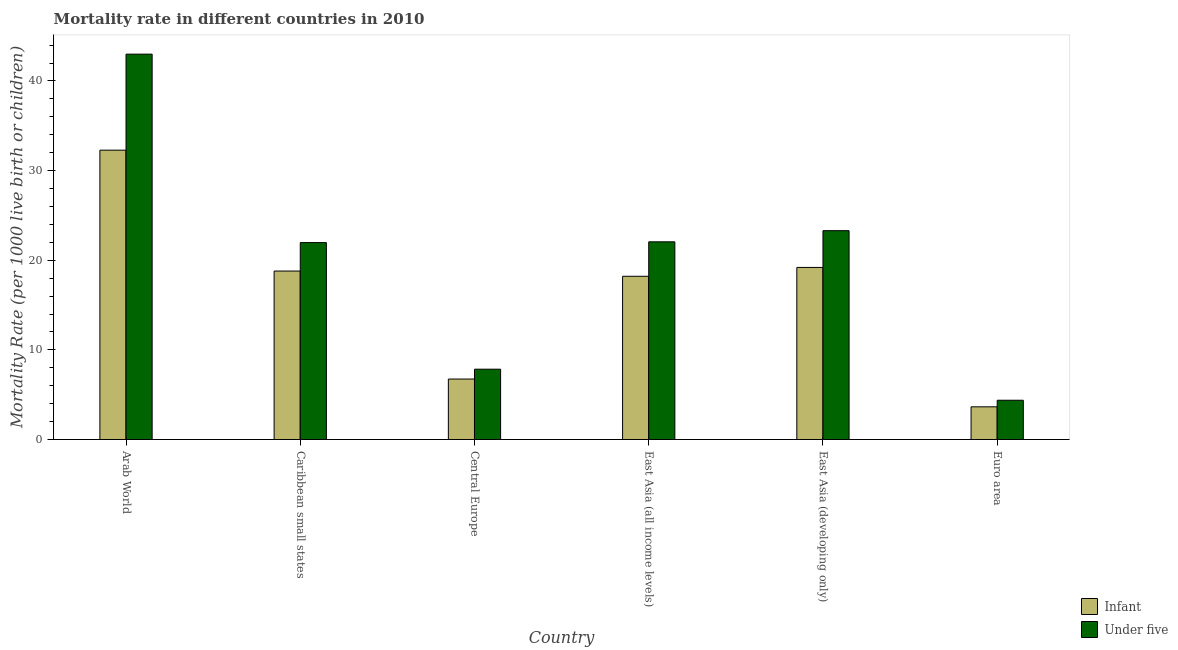How many groups of bars are there?
Your response must be concise. 6. How many bars are there on the 4th tick from the left?
Keep it short and to the point. 2. What is the label of the 5th group of bars from the left?
Offer a terse response. East Asia (developing only). In how many cases, is the number of bars for a given country not equal to the number of legend labels?
Your answer should be compact. 0. What is the under-5 mortality rate in Euro area?
Your answer should be compact. 4.38. Across all countries, what is the maximum under-5 mortality rate?
Ensure brevity in your answer.  42.99. Across all countries, what is the minimum infant mortality rate?
Your answer should be very brief. 3.65. In which country was the infant mortality rate maximum?
Your answer should be compact. Arab World. What is the total under-5 mortality rate in the graph?
Offer a very short reply. 122.55. What is the difference between the under-5 mortality rate in East Asia (all income levels) and that in Euro area?
Your response must be concise. 17.67. What is the difference between the under-5 mortality rate in East Asia (all income levels) and the infant mortality rate in Arab World?
Give a very brief answer. -10.23. What is the average under-5 mortality rate per country?
Give a very brief answer. 20.42. What is the difference between the under-5 mortality rate and infant mortality rate in Arab World?
Your answer should be very brief. 10.71. What is the ratio of the under-5 mortality rate in Central Europe to that in East Asia (all income levels)?
Make the answer very short. 0.36. Is the under-5 mortality rate in East Asia (all income levels) less than that in East Asia (developing only)?
Ensure brevity in your answer.  Yes. What is the difference between the highest and the second highest under-5 mortality rate?
Offer a very short reply. 19.69. What is the difference between the highest and the lowest under-5 mortality rate?
Your answer should be compact. 38.61. What does the 1st bar from the left in Caribbean small states represents?
Your answer should be very brief. Infant. What does the 2nd bar from the right in Euro area represents?
Ensure brevity in your answer.  Infant. How many bars are there?
Offer a terse response. 12. Does the graph contain any zero values?
Your answer should be compact. No. What is the title of the graph?
Ensure brevity in your answer.  Mortality rate in different countries in 2010. Does "Technicians" appear as one of the legend labels in the graph?
Make the answer very short. No. What is the label or title of the X-axis?
Provide a succinct answer. Country. What is the label or title of the Y-axis?
Offer a terse response. Mortality Rate (per 1000 live birth or children). What is the Mortality Rate (per 1000 live birth or children) of Infant in Arab World?
Offer a terse response. 32.28. What is the Mortality Rate (per 1000 live birth or children) in Under five in Arab World?
Provide a succinct answer. 42.99. What is the Mortality Rate (per 1000 live birth or children) of Infant in Caribbean small states?
Keep it short and to the point. 18.8. What is the Mortality Rate (per 1000 live birth or children) in Under five in Caribbean small states?
Provide a succinct answer. 21.97. What is the Mortality Rate (per 1000 live birth or children) in Infant in Central Europe?
Your answer should be compact. 6.75. What is the Mortality Rate (per 1000 live birth or children) in Under five in Central Europe?
Give a very brief answer. 7.85. What is the Mortality Rate (per 1000 live birth or children) of Infant in East Asia (all income levels)?
Ensure brevity in your answer.  18.21. What is the Mortality Rate (per 1000 live birth or children) of Under five in East Asia (all income levels)?
Your response must be concise. 22.06. What is the Mortality Rate (per 1000 live birth or children) of Under five in East Asia (developing only)?
Make the answer very short. 23.3. What is the Mortality Rate (per 1000 live birth or children) of Infant in Euro area?
Your response must be concise. 3.65. What is the Mortality Rate (per 1000 live birth or children) in Under five in Euro area?
Make the answer very short. 4.38. Across all countries, what is the maximum Mortality Rate (per 1000 live birth or children) of Infant?
Keep it short and to the point. 32.28. Across all countries, what is the maximum Mortality Rate (per 1000 live birth or children) of Under five?
Keep it short and to the point. 42.99. Across all countries, what is the minimum Mortality Rate (per 1000 live birth or children) in Infant?
Provide a succinct answer. 3.65. Across all countries, what is the minimum Mortality Rate (per 1000 live birth or children) of Under five?
Offer a very short reply. 4.38. What is the total Mortality Rate (per 1000 live birth or children) of Infant in the graph?
Provide a short and direct response. 98.89. What is the total Mortality Rate (per 1000 live birth or children) in Under five in the graph?
Make the answer very short. 122.55. What is the difference between the Mortality Rate (per 1000 live birth or children) of Infant in Arab World and that in Caribbean small states?
Make the answer very short. 13.48. What is the difference between the Mortality Rate (per 1000 live birth or children) in Under five in Arab World and that in Caribbean small states?
Make the answer very short. 21.03. What is the difference between the Mortality Rate (per 1000 live birth or children) of Infant in Arab World and that in Central Europe?
Offer a terse response. 25.54. What is the difference between the Mortality Rate (per 1000 live birth or children) in Under five in Arab World and that in Central Europe?
Your answer should be very brief. 35.15. What is the difference between the Mortality Rate (per 1000 live birth or children) in Infant in Arab World and that in East Asia (all income levels)?
Make the answer very short. 14.07. What is the difference between the Mortality Rate (per 1000 live birth or children) of Under five in Arab World and that in East Asia (all income levels)?
Keep it short and to the point. 20.94. What is the difference between the Mortality Rate (per 1000 live birth or children) of Infant in Arab World and that in East Asia (developing only)?
Your answer should be compact. 13.08. What is the difference between the Mortality Rate (per 1000 live birth or children) of Under five in Arab World and that in East Asia (developing only)?
Your answer should be compact. 19.69. What is the difference between the Mortality Rate (per 1000 live birth or children) in Infant in Arab World and that in Euro area?
Offer a terse response. 28.63. What is the difference between the Mortality Rate (per 1000 live birth or children) in Under five in Arab World and that in Euro area?
Make the answer very short. 38.61. What is the difference between the Mortality Rate (per 1000 live birth or children) of Infant in Caribbean small states and that in Central Europe?
Your response must be concise. 12.05. What is the difference between the Mortality Rate (per 1000 live birth or children) of Under five in Caribbean small states and that in Central Europe?
Your response must be concise. 14.12. What is the difference between the Mortality Rate (per 1000 live birth or children) in Infant in Caribbean small states and that in East Asia (all income levels)?
Provide a succinct answer. 0.59. What is the difference between the Mortality Rate (per 1000 live birth or children) in Under five in Caribbean small states and that in East Asia (all income levels)?
Ensure brevity in your answer.  -0.09. What is the difference between the Mortality Rate (per 1000 live birth or children) in Infant in Caribbean small states and that in East Asia (developing only)?
Your answer should be very brief. -0.4. What is the difference between the Mortality Rate (per 1000 live birth or children) of Under five in Caribbean small states and that in East Asia (developing only)?
Provide a succinct answer. -1.33. What is the difference between the Mortality Rate (per 1000 live birth or children) of Infant in Caribbean small states and that in Euro area?
Make the answer very short. 15.15. What is the difference between the Mortality Rate (per 1000 live birth or children) of Under five in Caribbean small states and that in Euro area?
Offer a very short reply. 17.59. What is the difference between the Mortality Rate (per 1000 live birth or children) of Infant in Central Europe and that in East Asia (all income levels)?
Provide a succinct answer. -11.46. What is the difference between the Mortality Rate (per 1000 live birth or children) of Under five in Central Europe and that in East Asia (all income levels)?
Provide a short and direct response. -14.21. What is the difference between the Mortality Rate (per 1000 live birth or children) of Infant in Central Europe and that in East Asia (developing only)?
Offer a very short reply. -12.45. What is the difference between the Mortality Rate (per 1000 live birth or children) of Under five in Central Europe and that in East Asia (developing only)?
Your answer should be very brief. -15.45. What is the difference between the Mortality Rate (per 1000 live birth or children) of Infant in Central Europe and that in Euro area?
Provide a succinct answer. 3.1. What is the difference between the Mortality Rate (per 1000 live birth or children) of Under five in Central Europe and that in Euro area?
Make the answer very short. 3.46. What is the difference between the Mortality Rate (per 1000 live birth or children) of Infant in East Asia (all income levels) and that in East Asia (developing only)?
Your answer should be compact. -0.99. What is the difference between the Mortality Rate (per 1000 live birth or children) of Under five in East Asia (all income levels) and that in East Asia (developing only)?
Your answer should be compact. -1.24. What is the difference between the Mortality Rate (per 1000 live birth or children) in Infant in East Asia (all income levels) and that in Euro area?
Ensure brevity in your answer.  14.56. What is the difference between the Mortality Rate (per 1000 live birth or children) in Under five in East Asia (all income levels) and that in Euro area?
Keep it short and to the point. 17.67. What is the difference between the Mortality Rate (per 1000 live birth or children) of Infant in East Asia (developing only) and that in Euro area?
Ensure brevity in your answer.  15.55. What is the difference between the Mortality Rate (per 1000 live birth or children) of Under five in East Asia (developing only) and that in Euro area?
Provide a short and direct response. 18.92. What is the difference between the Mortality Rate (per 1000 live birth or children) in Infant in Arab World and the Mortality Rate (per 1000 live birth or children) in Under five in Caribbean small states?
Offer a terse response. 10.31. What is the difference between the Mortality Rate (per 1000 live birth or children) in Infant in Arab World and the Mortality Rate (per 1000 live birth or children) in Under five in Central Europe?
Offer a very short reply. 24.44. What is the difference between the Mortality Rate (per 1000 live birth or children) of Infant in Arab World and the Mortality Rate (per 1000 live birth or children) of Under five in East Asia (all income levels)?
Offer a very short reply. 10.23. What is the difference between the Mortality Rate (per 1000 live birth or children) of Infant in Arab World and the Mortality Rate (per 1000 live birth or children) of Under five in East Asia (developing only)?
Provide a short and direct response. 8.98. What is the difference between the Mortality Rate (per 1000 live birth or children) of Infant in Arab World and the Mortality Rate (per 1000 live birth or children) of Under five in Euro area?
Ensure brevity in your answer.  27.9. What is the difference between the Mortality Rate (per 1000 live birth or children) of Infant in Caribbean small states and the Mortality Rate (per 1000 live birth or children) of Under five in Central Europe?
Give a very brief answer. 10.95. What is the difference between the Mortality Rate (per 1000 live birth or children) in Infant in Caribbean small states and the Mortality Rate (per 1000 live birth or children) in Under five in East Asia (all income levels)?
Give a very brief answer. -3.26. What is the difference between the Mortality Rate (per 1000 live birth or children) in Infant in Caribbean small states and the Mortality Rate (per 1000 live birth or children) in Under five in East Asia (developing only)?
Provide a succinct answer. -4.5. What is the difference between the Mortality Rate (per 1000 live birth or children) of Infant in Caribbean small states and the Mortality Rate (per 1000 live birth or children) of Under five in Euro area?
Offer a very short reply. 14.42. What is the difference between the Mortality Rate (per 1000 live birth or children) in Infant in Central Europe and the Mortality Rate (per 1000 live birth or children) in Under five in East Asia (all income levels)?
Provide a succinct answer. -15.31. What is the difference between the Mortality Rate (per 1000 live birth or children) in Infant in Central Europe and the Mortality Rate (per 1000 live birth or children) in Under five in East Asia (developing only)?
Make the answer very short. -16.55. What is the difference between the Mortality Rate (per 1000 live birth or children) in Infant in Central Europe and the Mortality Rate (per 1000 live birth or children) in Under five in Euro area?
Give a very brief answer. 2.37. What is the difference between the Mortality Rate (per 1000 live birth or children) of Infant in East Asia (all income levels) and the Mortality Rate (per 1000 live birth or children) of Under five in East Asia (developing only)?
Give a very brief answer. -5.09. What is the difference between the Mortality Rate (per 1000 live birth or children) of Infant in East Asia (all income levels) and the Mortality Rate (per 1000 live birth or children) of Under five in Euro area?
Provide a short and direct response. 13.83. What is the difference between the Mortality Rate (per 1000 live birth or children) of Infant in East Asia (developing only) and the Mortality Rate (per 1000 live birth or children) of Under five in Euro area?
Ensure brevity in your answer.  14.82. What is the average Mortality Rate (per 1000 live birth or children) in Infant per country?
Your response must be concise. 16.48. What is the average Mortality Rate (per 1000 live birth or children) in Under five per country?
Offer a terse response. 20.42. What is the difference between the Mortality Rate (per 1000 live birth or children) of Infant and Mortality Rate (per 1000 live birth or children) of Under five in Arab World?
Ensure brevity in your answer.  -10.71. What is the difference between the Mortality Rate (per 1000 live birth or children) of Infant and Mortality Rate (per 1000 live birth or children) of Under five in Caribbean small states?
Your answer should be very brief. -3.17. What is the difference between the Mortality Rate (per 1000 live birth or children) of Infant and Mortality Rate (per 1000 live birth or children) of Under five in Central Europe?
Your answer should be compact. -1.1. What is the difference between the Mortality Rate (per 1000 live birth or children) in Infant and Mortality Rate (per 1000 live birth or children) in Under five in East Asia (all income levels)?
Your answer should be very brief. -3.84. What is the difference between the Mortality Rate (per 1000 live birth or children) of Infant and Mortality Rate (per 1000 live birth or children) of Under five in East Asia (developing only)?
Offer a very short reply. -4.1. What is the difference between the Mortality Rate (per 1000 live birth or children) in Infant and Mortality Rate (per 1000 live birth or children) in Under five in Euro area?
Your answer should be very brief. -0.73. What is the ratio of the Mortality Rate (per 1000 live birth or children) of Infant in Arab World to that in Caribbean small states?
Make the answer very short. 1.72. What is the ratio of the Mortality Rate (per 1000 live birth or children) in Under five in Arab World to that in Caribbean small states?
Provide a short and direct response. 1.96. What is the ratio of the Mortality Rate (per 1000 live birth or children) of Infant in Arab World to that in Central Europe?
Provide a short and direct response. 4.78. What is the ratio of the Mortality Rate (per 1000 live birth or children) of Under five in Arab World to that in Central Europe?
Offer a very short reply. 5.48. What is the ratio of the Mortality Rate (per 1000 live birth or children) of Infant in Arab World to that in East Asia (all income levels)?
Your response must be concise. 1.77. What is the ratio of the Mortality Rate (per 1000 live birth or children) of Under five in Arab World to that in East Asia (all income levels)?
Your answer should be very brief. 1.95. What is the ratio of the Mortality Rate (per 1000 live birth or children) in Infant in Arab World to that in East Asia (developing only)?
Your answer should be very brief. 1.68. What is the ratio of the Mortality Rate (per 1000 live birth or children) in Under five in Arab World to that in East Asia (developing only)?
Keep it short and to the point. 1.85. What is the ratio of the Mortality Rate (per 1000 live birth or children) of Infant in Arab World to that in Euro area?
Offer a terse response. 8.85. What is the ratio of the Mortality Rate (per 1000 live birth or children) of Under five in Arab World to that in Euro area?
Your answer should be compact. 9.81. What is the ratio of the Mortality Rate (per 1000 live birth or children) of Infant in Caribbean small states to that in Central Europe?
Offer a very short reply. 2.79. What is the ratio of the Mortality Rate (per 1000 live birth or children) in Under five in Caribbean small states to that in Central Europe?
Keep it short and to the point. 2.8. What is the ratio of the Mortality Rate (per 1000 live birth or children) in Infant in Caribbean small states to that in East Asia (all income levels)?
Your answer should be compact. 1.03. What is the ratio of the Mortality Rate (per 1000 live birth or children) of Infant in Caribbean small states to that in East Asia (developing only)?
Keep it short and to the point. 0.98. What is the ratio of the Mortality Rate (per 1000 live birth or children) of Under five in Caribbean small states to that in East Asia (developing only)?
Your answer should be compact. 0.94. What is the ratio of the Mortality Rate (per 1000 live birth or children) of Infant in Caribbean small states to that in Euro area?
Offer a terse response. 5.15. What is the ratio of the Mortality Rate (per 1000 live birth or children) in Under five in Caribbean small states to that in Euro area?
Offer a terse response. 5.01. What is the ratio of the Mortality Rate (per 1000 live birth or children) in Infant in Central Europe to that in East Asia (all income levels)?
Keep it short and to the point. 0.37. What is the ratio of the Mortality Rate (per 1000 live birth or children) in Under five in Central Europe to that in East Asia (all income levels)?
Give a very brief answer. 0.36. What is the ratio of the Mortality Rate (per 1000 live birth or children) in Infant in Central Europe to that in East Asia (developing only)?
Your response must be concise. 0.35. What is the ratio of the Mortality Rate (per 1000 live birth or children) in Under five in Central Europe to that in East Asia (developing only)?
Keep it short and to the point. 0.34. What is the ratio of the Mortality Rate (per 1000 live birth or children) in Infant in Central Europe to that in Euro area?
Offer a terse response. 1.85. What is the ratio of the Mortality Rate (per 1000 live birth or children) of Under five in Central Europe to that in Euro area?
Provide a short and direct response. 1.79. What is the ratio of the Mortality Rate (per 1000 live birth or children) of Infant in East Asia (all income levels) to that in East Asia (developing only)?
Give a very brief answer. 0.95. What is the ratio of the Mortality Rate (per 1000 live birth or children) of Under five in East Asia (all income levels) to that in East Asia (developing only)?
Offer a terse response. 0.95. What is the ratio of the Mortality Rate (per 1000 live birth or children) of Infant in East Asia (all income levels) to that in Euro area?
Provide a short and direct response. 4.99. What is the ratio of the Mortality Rate (per 1000 live birth or children) in Under five in East Asia (all income levels) to that in Euro area?
Offer a very short reply. 5.03. What is the ratio of the Mortality Rate (per 1000 live birth or children) in Infant in East Asia (developing only) to that in Euro area?
Provide a succinct answer. 5.26. What is the ratio of the Mortality Rate (per 1000 live birth or children) in Under five in East Asia (developing only) to that in Euro area?
Offer a very short reply. 5.32. What is the difference between the highest and the second highest Mortality Rate (per 1000 live birth or children) in Infant?
Offer a terse response. 13.08. What is the difference between the highest and the second highest Mortality Rate (per 1000 live birth or children) of Under five?
Offer a very short reply. 19.69. What is the difference between the highest and the lowest Mortality Rate (per 1000 live birth or children) of Infant?
Keep it short and to the point. 28.63. What is the difference between the highest and the lowest Mortality Rate (per 1000 live birth or children) in Under five?
Provide a short and direct response. 38.61. 